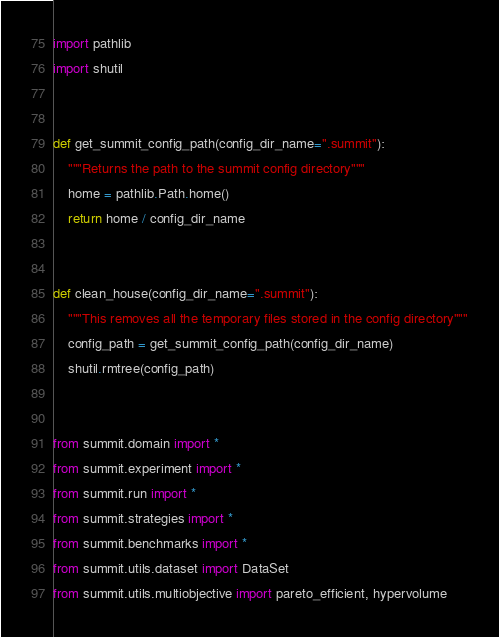Convert code to text. <code><loc_0><loc_0><loc_500><loc_500><_Python_>import pathlib
import shutil


def get_summit_config_path(config_dir_name=".summit"):
    """Returns the path to the summit config directory"""
    home = pathlib.Path.home()
    return home / config_dir_name


def clean_house(config_dir_name=".summit"):
    """This removes all the temporary files stored in the config directory"""
    config_path = get_summit_config_path(config_dir_name)
    shutil.rmtree(config_path)


from summit.domain import *
from summit.experiment import *
from summit.run import *
from summit.strategies import *
from summit.benchmarks import *
from summit.utils.dataset import DataSet
from summit.utils.multiobjective import pareto_efficient, hypervolume
</code> 